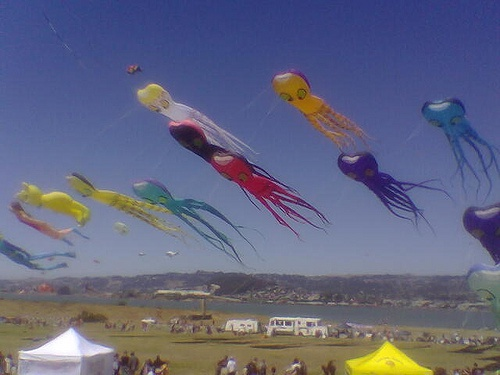Describe the objects in this image and their specific colors. I can see kite in blue, gray, and navy tones, kite in blue, gray, purple, and black tones, kite in blue, gray, olive, and purple tones, kite in blue, gray, and darkblue tones, and kite in blue and gray tones in this image. 